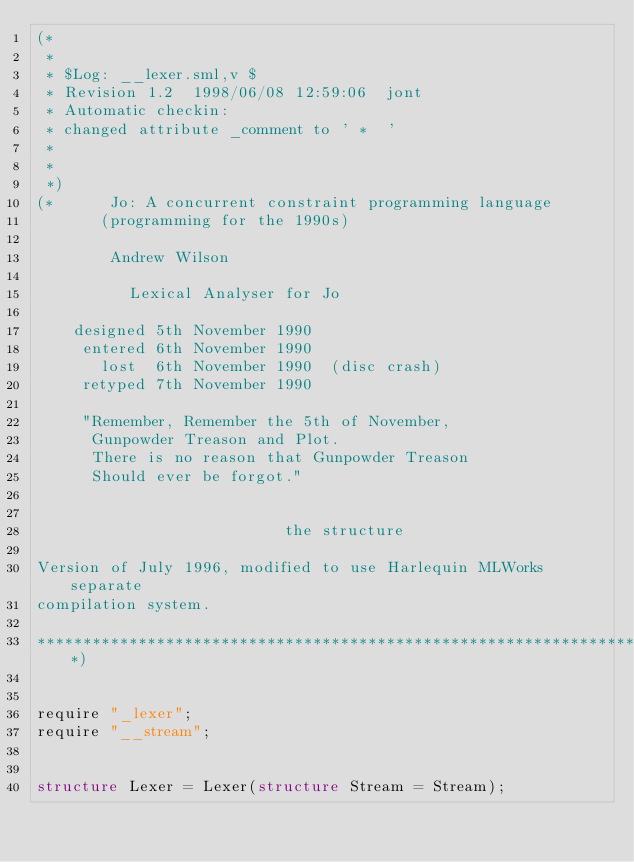Convert code to text. <code><loc_0><loc_0><loc_500><loc_500><_SML_>(*
 *
 * $Log: __lexer.sml,v $
 * Revision 1.2  1998/06/08 12:59:06  jont
 * Automatic checkin:
 * changed attribute _comment to ' *  '
 *
 *
 *)
(*	    Jo: A concurrent constraint programming language
		   (programming for the 1990s)

			  Andrew Wilson

		      Lexical Analyser for Jo

		designed 5th November 1990
		 entered 6th November 1990
		   lost  6th November 1990  (disc crash)
		 retyped 7th November 1990

		 "Remember, Remember the 5th of November,
		  Gunpowder Treason and Plot.
		  There is no reason that Gunpowder Treason
		  Should ever be forgot."


                           the structure

Version of July 1996, modified to use Harlequin MLWorks separate
compilation system.

*****************************************************************************)


require "_lexer";
require "__stream";


structure Lexer = Lexer(structure Stream = Stream);

</code> 